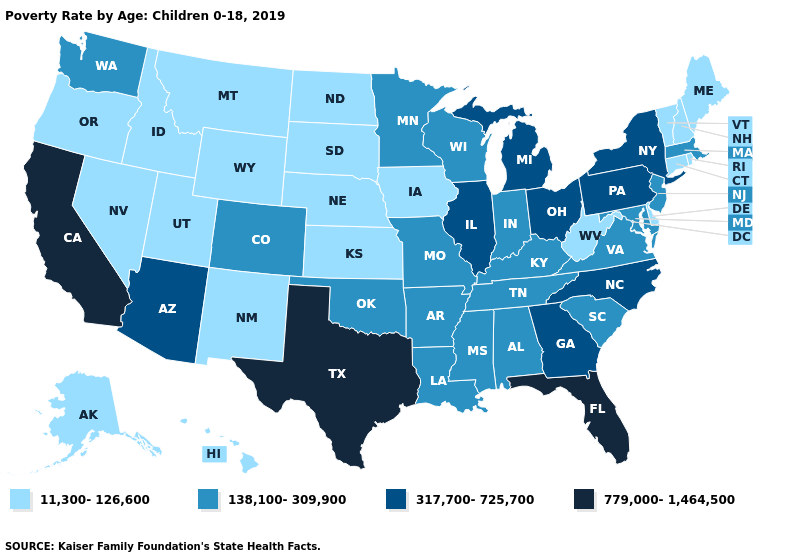Which states have the lowest value in the USA?
Answer briefly. Alaska, Connecticut, Delaware, Hawaii, Idaho, Iowa, Kansas, Maine, Montana, Nebraska, Nevada, New Hampshire, New Mexico, North Dakota, Oregon, Rhode Island, South Dakota, Utah, Vermont, West Virginia, Wyoming. Name the states that have a value in the range 138,100-309,900?
Quick response, please. Alabama, Arkansas, Colorado, Indiana, Kentucky, Louisiana, Maryland, Massachusetts, Minnesota, Mississippi, Missouri, New Jersey, Oklahoma, South Carolina, Tennessee, Virginia, Washington, Wisconsin. Does Montana have the same value as Rhode Island?
Give a very brief answer. Yes. Does Oklahoma have a higher value than Missouri?
Answer briefly. No. Among the states that border Vermont , which have the lowest value?
Answer briefly. New Hampshire. What is the highest value in the MidWest ?
Write a very short answer. 317,700-725,700. Name the states that have a value in the range 779,000-1,464,500?
Quick response, please. California, Florida, Texas. What is the value of Wyoming?
Keep it brief. 11,300-126,600. What is the value of Oregon?
Short answer required. 11,300-126,600. What is the lowest value in the Northeast?
Quick response, please. 11,300-126,600. Does North Carolina have the highest value in the USA?
Write a very short answer. No. Which states have the lowest value in the MidWest?
Keep it brief. Iowa, Kansas, Nebraska, North Dakota, South Dakota. What is the highest value in the USA?
Short answer required. 779,000-1,464,500. Name the states that have a value in the range 317,700-725,700?
Give a very brief answer. Arizona, Georgia, Illinois, Michigan, New York, North Carolina, Ohio, Pennsylvania. What is the highest value in the USA?
Answer briefly. 779,000-1,464,500. 